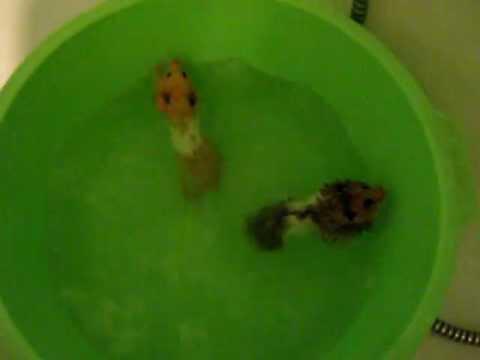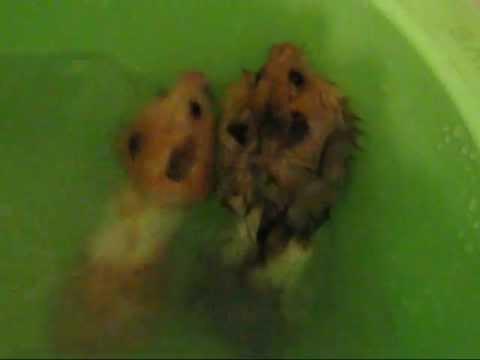The first image is the image on the left, the second image is the image on the right. Analyze the images presented: Is the assertion "At least one hamster is swimming in the water." valid? Answer yes or no. Yes. The first image is the image on the left, the second image is the image on the right. Examine the images to the left and right. Is the description "Each image shows at least one hamster on a green surface, and at least one image shows a hamster in a round green plastic object." accurate? Answer yes or no. Yes. 